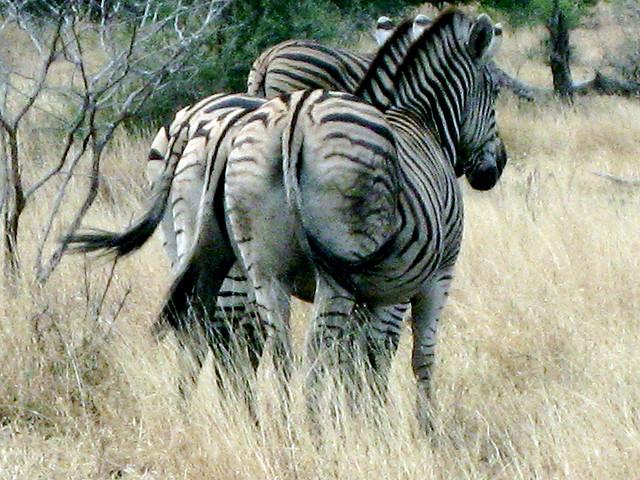How many zebras are there?
Keep it brief. 3. Is this picture taken in the wild?
Answer briefly. Yes. Are the animals moving in the same direction?
Concise answer only. Yes. Are the animals drinking water?
Quick response, please. No. Are the animals free on the field?
Keep it brief. Yes. 